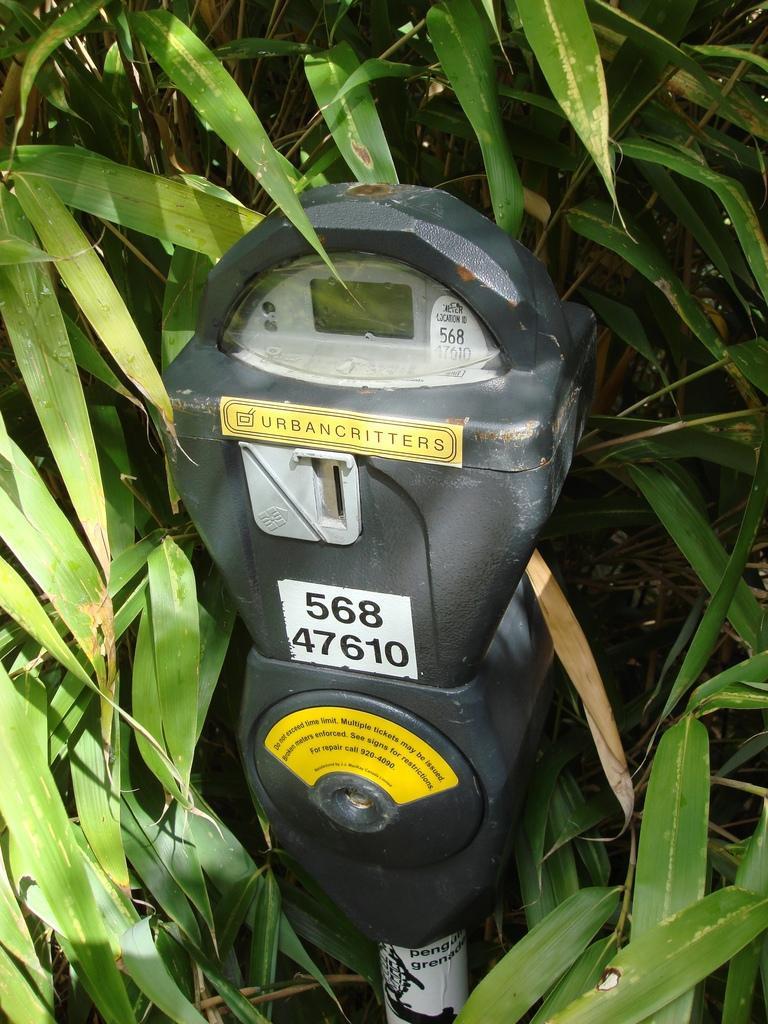<image>
Share a concise interpretation of the image provided. A parking meter is obscured by foilage and has a sticker upon it which says Urbancritters. 